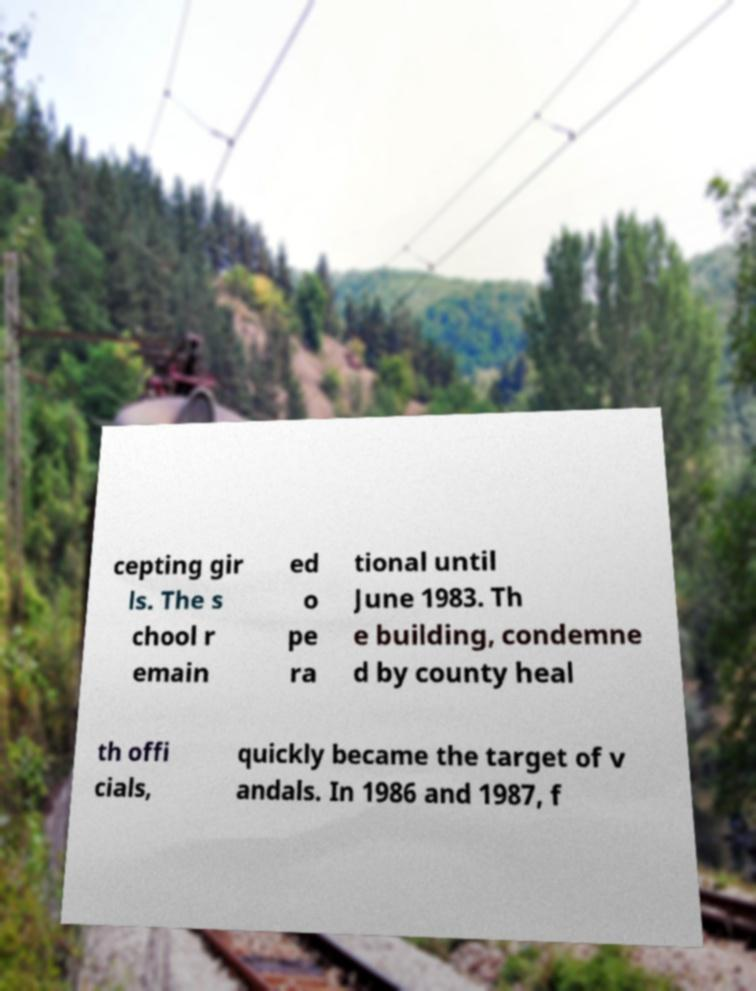There's text embedded in this image that I need extracted. Can you transcribe it verbatim? cepting gir ls. The s chool r emain ed o pe ra tional until June 1983. Th e building, condemne d by county heal th offi cials, quickly became the target of v andals. In 1986 and 1987, f 